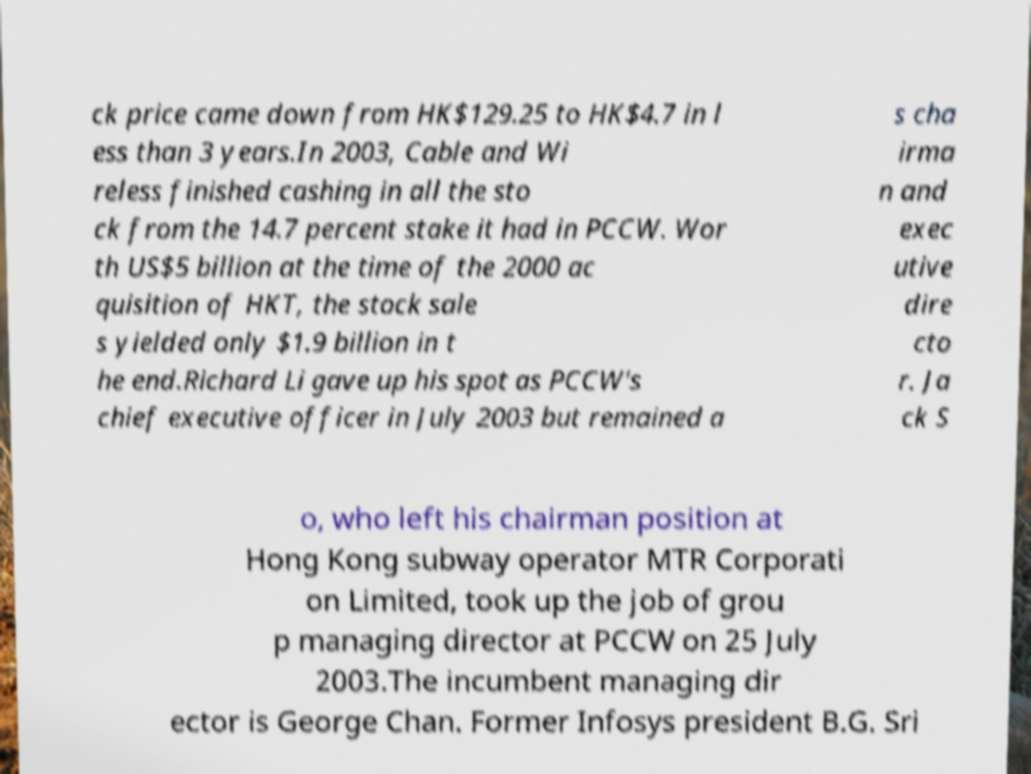There's text embedded in this image that I need extracted. Can you transcribe it verbatim? ck price came down from HK$129.25 to HK$4.7 in l ess than 3 years.In 2003, Cable and Wi reless finished cashing in all the sto ck from the 14.7 percent stake it had in PCCW. Wor th US$5 billion at the time of the 2000 ac quisition of HKT, the stock sale s yielded only $1.9 billion in t he end.Richard Li gave up his spot as PCCW's chief executive officer in July 2003 but remained a s cha irma n and exec utive dire cto r. Ja ck S o, who left his chairman position at Hong Kong subway operator MTR Corporati on Limited, took up the job of grou p managing director at PCCW on 25 July 2003.The incumbent managing dir ector is George Chan. Former Infosys president B.G. Sri 